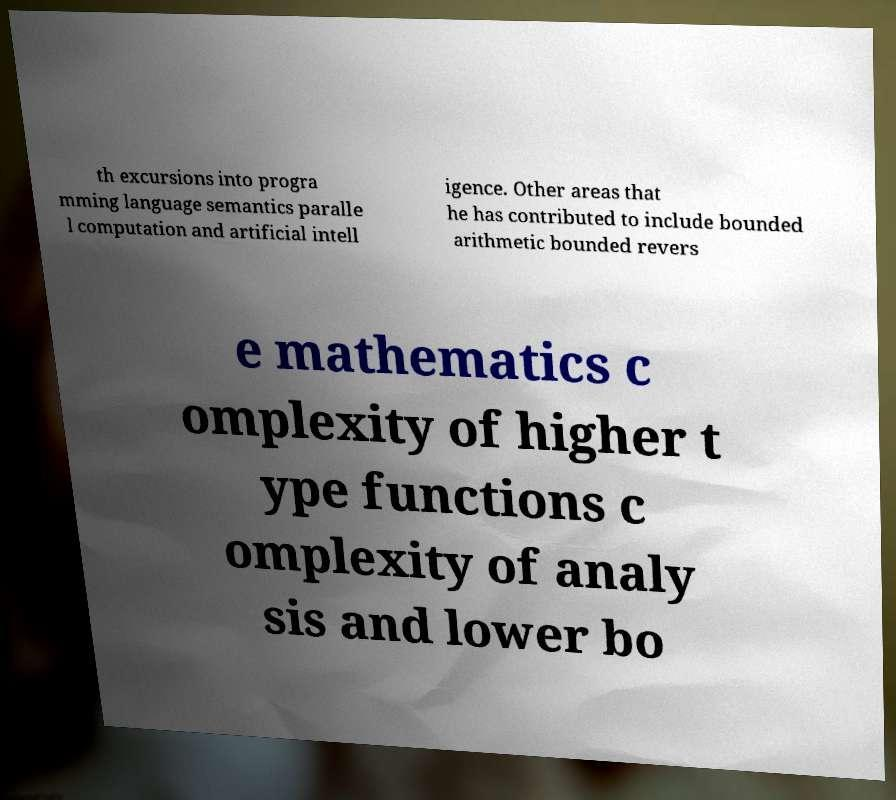Could you extract and type out the text from this image? th excursions into progra mming language semantics paralle l computation and artificial intell igence. Other areas that he has contributed to include bounded arithmetic bounded revers e mathematics c omplexity of higher t ype functions c omplexity of analy sis and lower bo 